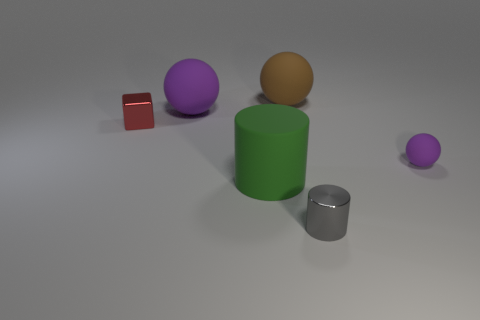Subtract all big rubber balls. How many balls are left? 1 Add 3 small cylinders. How many objects exist? 9 Subtract 1 cylinders. How many cylinders are left? 1 Subtract all gray cylinders. How many cylinders are left? 1 Subtract all blocks. How many objects are left? 5 Subtract all red spheres. How many green cylinders are left? 1 Add 3 purple matte balls. How many purple matte balls exist? 5 Subtract 0 green spheres. How many objects are left? 6 Subtract all gray balls. Subtract all blue cylinders. How many balls are left? 3 Subtract all large purple matte spheres. Subtract all large rubber spheres. How many objects are left? 3 